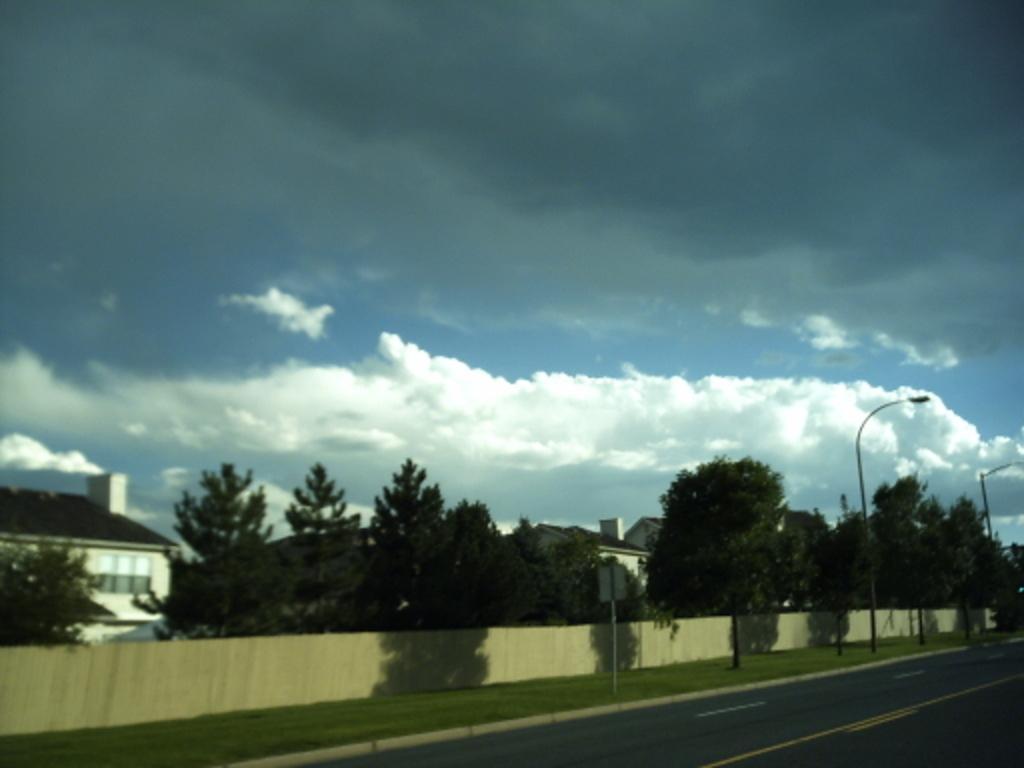Please provide a concise description of this image. There are trees and houses, this is road and a sky. 